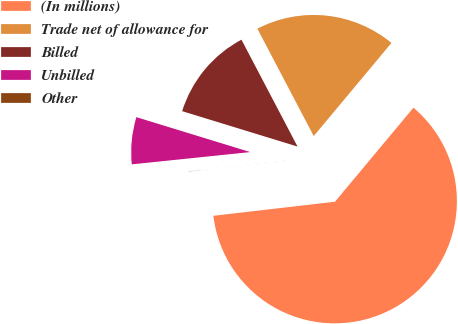Convert chart to OTSL. <chart><loc_0><loc_0><loc_500><loc_500><pie_chart><fcel>(In millions)<fcel>Trade net of allowance for<fcel>Billed<fcel>Unbilled<fcel>Other<nl><fcel>62.1%<fcel>18.76%<fcel>12.57%<fcel>6.38%<fcel>0.19%<nl></chart> 